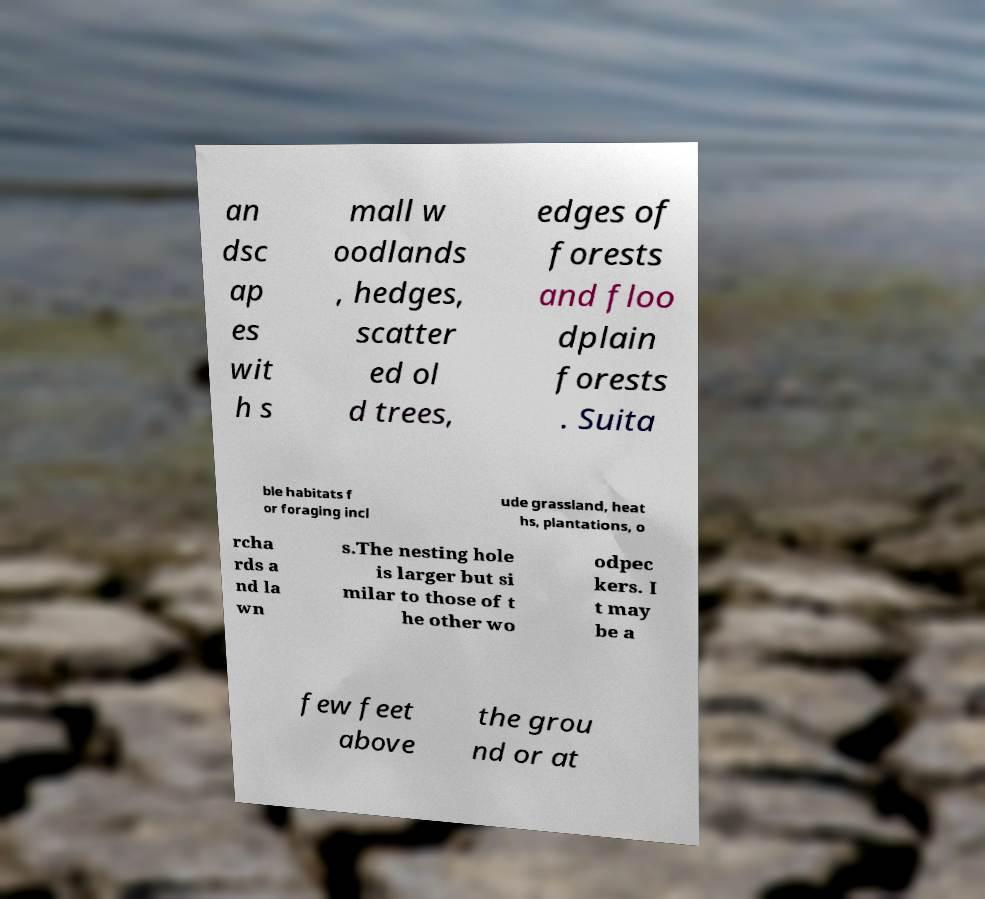Could you assist in decoding the text presented in this image and type it out clearly? an dsc ap es wit h s mall w oodlands , hedges, scatter ed ol d trees, edges of forests and floo dplain forests . Suita ble habitats f or foraging incl ude grassland, heat hs, plantations, o rcha rds a nd la wn s.The nesting hole is larger but si milar to those of t he other wo odpec kers. I t may be a few feet above the grou nd or at 